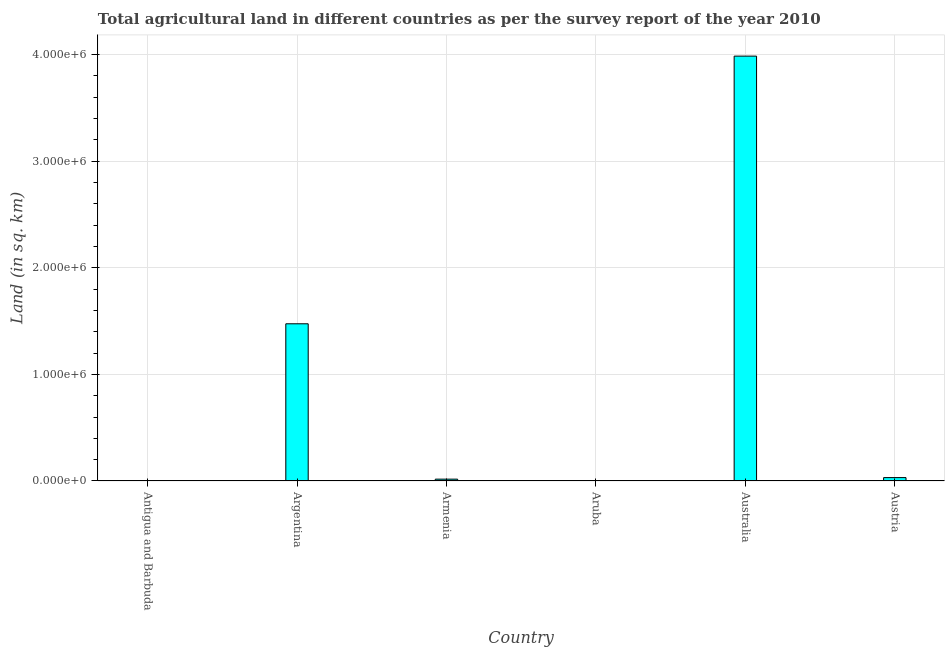Does the graph contain any zero values?
Ensure brevity in your answer.  No. What is the title of the graph?
Your response must be concise. Total agricultural land in different countries as per the survey report of the year 2010. What is the label or title of the X-axis?
Offer a very short reply. Country. What is the label or title of the Y-axis?
Your answer should be very brief. Land (in sq. km). What is the agricultural land in Armenia?
Make the answer very short. 1.74e+04. Across all countries, what is the maximum agricultural land?
Offer a terse response. 3.99e+06. In which country was the agricultural land maximum?
Your response must be concise. Australia. In which country was the agricultural land minimum?
Offer a terse response. Aruba. What is the sum of the agricultural land?
Keep it short and to the point. 5.51e+06. What is the difference between the agricultural land in Antigua and Barbuda and Armenia?
Offer a very short reply. -1.73e+04. What is the average agricultural land per country?
Offer a terse response. 9.18e+05. What is the median agricultural land?
Give a very brief answer. 2.46e+04. What is the ratio of the agricultural land in Argentina to that in Armenia?
Your answer should be very brief. 85. Is the difference between the agricultural land in Antigua and Barbuda and Australia greater than the difference between any two countries?
Make the answer very short. No. What is the difference between the highest and the second highest agricultural land?
Your answer should be compact. 2.51e+06. Is the sum of the agricultural land in Armenia and Aruba greater than the maximum agricultural land across all countries?
Provide a succinct answer. No. What is the difference between the highest and the lowest agricultural land?
Keep it short and to the point. 3.99e+06. Are all the bars in the graph horizontal?
Your response must be concise. No. What is the difference between two consecutive major ticks on the Y-axis?
Provide a short and direct response. 1.00e+06. What is the Land (in sq. km) in Antigua and Barbuda?
Ensure brevity in your answer.  90. What is the Land (in sq. km) of Argentina?
Offer a very short reply. 1.47e+06. What is the Land (in sq. km) of Armenia?
Your answer should be very brief. 1.74e+04. What is the Land (in sq. km) of Aruba?
Ensure brevity in your answer.  20. What is the Land (in sq. km) in Australia?
Offer a terse response. 3.99e+06. What is the Land (in sq. km) in Austria?
Keep it short and to the point. 3.18e+04. What is the difference between the Land (in sq. km) in Antigua and Barbuda and Argentina?
Offer a terse response. -1.47e+06. What is the difference between the Land (in sq. km) in Antigua and Barbuda and Armenia?
Your response must be concise. -1.73e+04. What is the difference between the Land (in sq. km) in Antigua and Barbuda and Australia?
Keep it short and to the point. -3.99e+06. What is the difference between the Land (in sq. km) in Antigua and Barbuda and Austria?
Your response must be concise. -3.18e+04. What is the difference between the Land (in sq. km) in Argentina and Armenia?
Ensure brevity in your answer.  1.46e+06. What is the difference between the Land (in sq. km) in Argentina and Aruba?
Make the answer very short. 1.47e+06. What is the difference between the Land (in sq. km) in Argentina and Australia?
Your answer should be compact. -2.51e+06. What is the difference between the Land (in sq. km) in Argentina and Austria?
Your answer should be compact. 1.44e+06. What is the difference between the Land (in sq. km) in Armenia and Aruba?
Give a very brief answer. 1.73e+04. What is the difference between the Land (in sq. km) in Armenia and Australia?
Provide a short and direct response. -3.97e+06. What is the difference between the Land (in sq. km) in Armenia and Austria?
Give a very brief answer. -1.45e+04. What is the difference between the Land (in sq. km) in Aruba and Australia?
Give a very brief answer. -3.99e+06. What is the difference between the Land (in sq. km) in Aruba and Austria?
Make the answer very short. -3.18e+04. What is the difference between the Land (in sq. km) in Australia and Austria?
Keep it short and to the point. 3.95e+06. What is the ratio of the Land (in sq. km) in Antigua and Barbuda to that in Armenia?
Make the answer very short. 0.01. What is the ratio of the Land (in sq. km) in Antigua and Barbuda to that in Aruba?
Provide a short and direct response. 4.5. What is the ratio of the Land (in sq. km) in Antigua and Barbuda to that in Austria?
Your response must be concise. 0. What is the ratio of the Land (in sq. km) in Argentina to that in Armenia?
Provide a succinct answer. 85. What is the ratio of the Land (in sq. km) in Argentina to that in Aruba?
Offer a terse response. 7.37e+04. What is the ratio of the Land (in sq. km) in Argentina to that in Australia?
Provide a short and direct response. 0.37. What is the ratio of the Land (in sq. km) in Argentina to that in Austria?
Provide a succinct answer. 46.31. What is the ratio of the Land (in sq. km) in Armenia to that in Aruba?
Provide a succinct answer. 867.5. What is the ratio of the Land (in sq. km) in Armenia to that in Australia?
Provide a succinct answer. 0. What is the ratio of the Land (in sq. km) in Armenia to that in Austria?
Keep it short and to the point. 0.55. What is the ratio of the Land (in sq. km) in Aruba to that in Australia?
Provide a succinct answer. 0. What is the ratio of the Land (in sq. km) in Australia to that in Austria?
Keep it short and to the point. 125.15. 